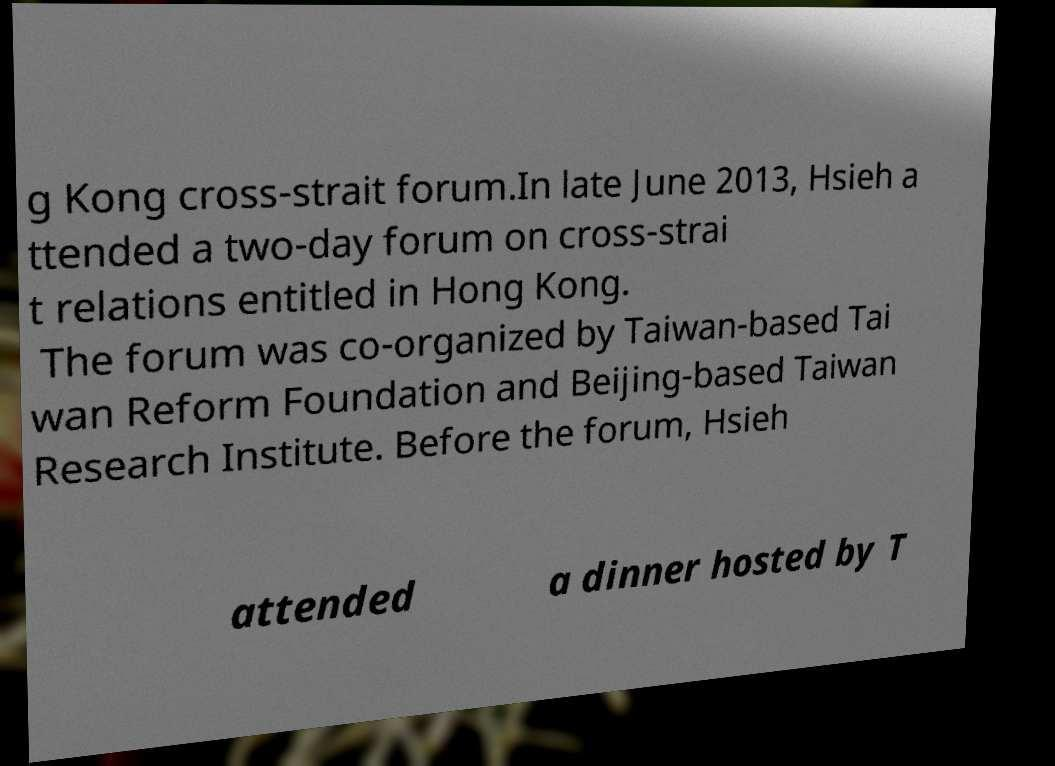For documentation purposes, I need the text within this image transcribed. Could you provide that? g Kong cross-strait forum.In late June 2013, Hsieh a ttended a two-day forum on cross-strai t relations entitled in Hong Kong. The forum was co-organized by Taiwan-based Tai wan Reform Foundation and Beijing-based Taiwan Research Institute. Before the forum, Hsieh attended a dinner hosted by T 